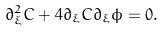Convert formula to latex. <formula><loc_0><loc_0><loc_500><loc_500>\partial _ { \xi } ^ { 2 } C + 4 \partial _ { \xi } C \partial _ { \xi } \phi = 0 .</formula> 